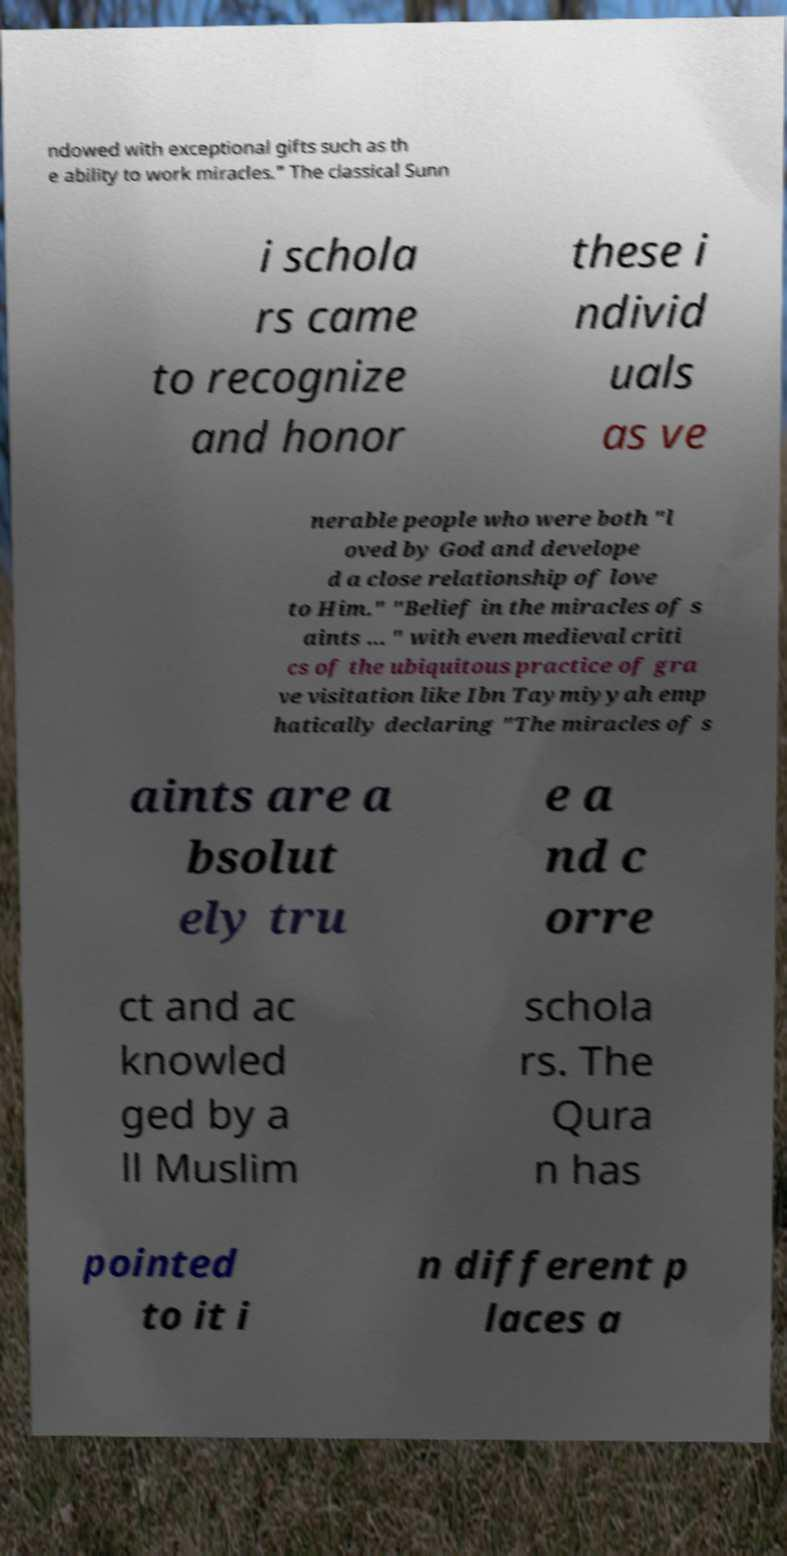Please identify and transcribe the text found in this image. ndowed with exceptional gifts such as th e ability to work miracles." The classical Sunn i schola rs came to recognize and honor these i ndivid uals as ve nerable people who were both "l oved by God and develope d a close relationship of love to Him." "Belief in the miracles of s aints ... " with even medieval criti cs of the ubiquitous practice of gra ve visitation like Ibn Taymiyyah emp hatically declaring "The miracles of s aints are a bsolut ely tru e a nd c orre ct and ac knowled ged by a ll Muslim schola rs. The Qura n has pointed to it i n different p laces a 